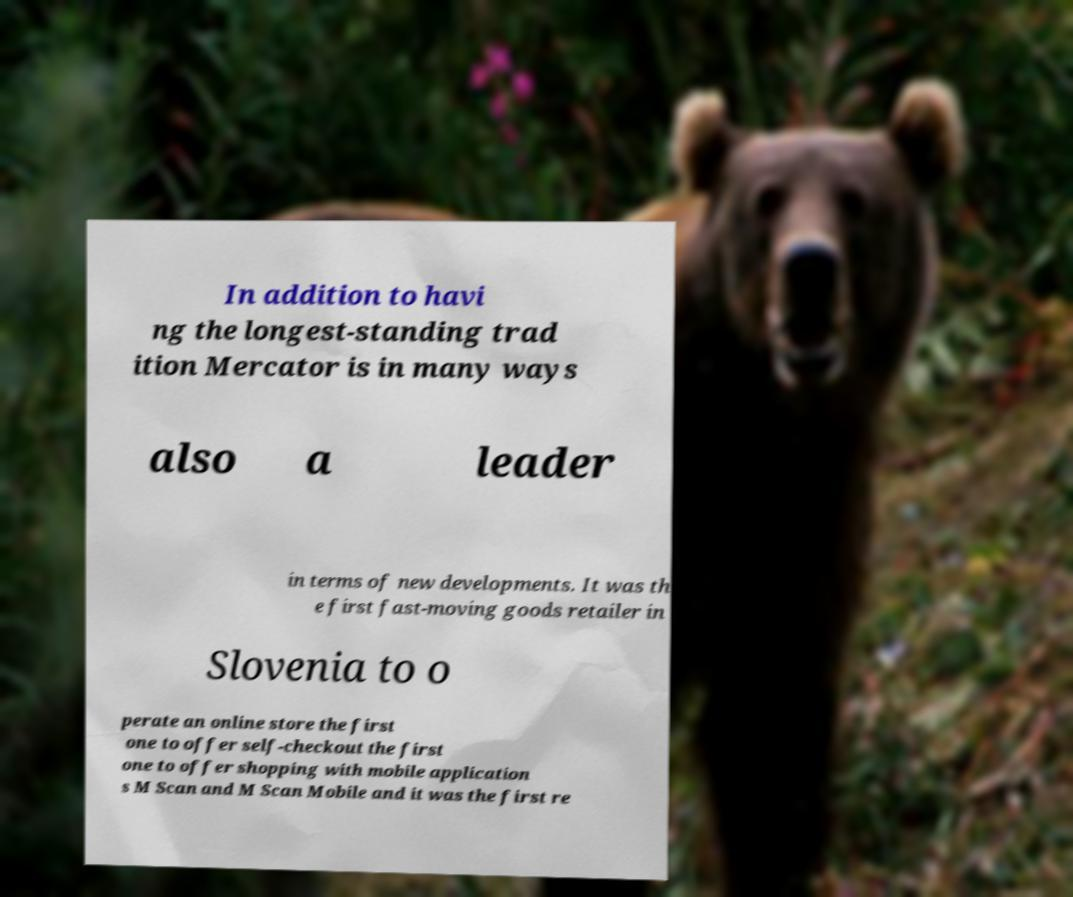There's text embedded in this image that I need extracted. Can you transcribe it verbatim? In addition to havi ng the longest-standing trad ition Mercator is in many ways also a leader in terms of new developments. It was th e first fast-moving goods retailer in Slovenia to o perate an online store the first one to offer self-checkout the first one to offer shopping with mobile application s M Scan and M Scan Mobile and it was the first re 